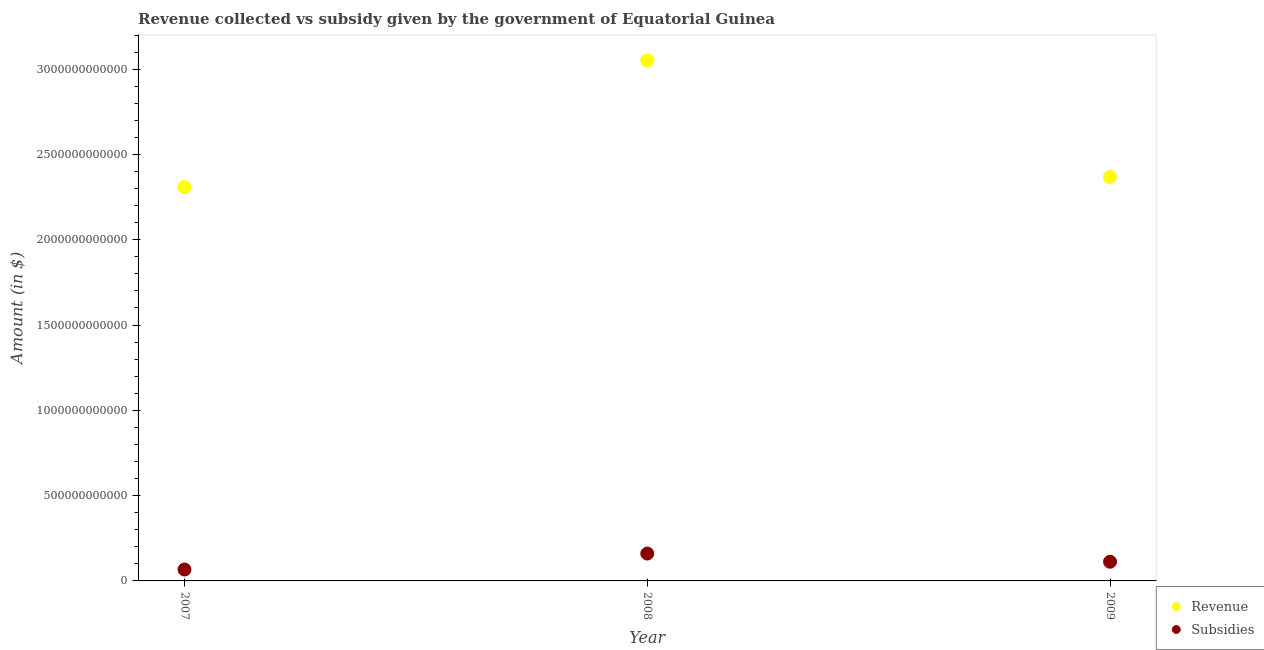How many different coloured dotlines are there?
Your response must be concise. 2. Is the number of dotlines equal to the number of legend labels?
Make the answer very short. Yes. What is the amount of subsidies given in 2009?
Keep it short and to the point. 1.12e+11. Across all years, what is the maximum amount of revenue collected?
Provide a short and direct response. 3.05e+12. Across all years, what is the minimum amount of subsidies given?
Offer a terse response. 6.67e+1. In which year was the amount of revenue collected maximum?
Keep it short and to the point. 2008. In which year was the amount of subsidies given minimum?
Make the answer very short. 2007. What is the total amount of subsidies given in the graph?
Ensure brevity in your answer.  3.40e+11. What is the difference between the amount of revenue collected in 2008 and that in 2009?
Make the answer very short. 6.84e+11. What is the difference between the amount of subsidies given in 2009 and the amount of revenue collected in 2008?
Ensure brevity in your answer.  -2.94e+12. What is the average amount of subsidies given per year?
Ensure brevity in your answer.  1.13e+11. In the year 2008, what is the difference between the amount of subsidies given and amount of revenue collected?
Your response must be concise. -2.89e+12. In how many years, is the amount of subsidies given greater than 1400000000000 $?
Keep it short and to the point. 0. What is the ratio of the amount of revenue collected in 2008 to that in 2009?
Make the answer very short. 1.29. Is the difference between the amount of revenue collected in 2007 and 2009 greater than the difference between the amount of subsidies given in 2007 and 2009?
Give a very brief answer. No. What is the difference between the highest and the second highest amount of subsidies given?
Provide a short and direct response. 4.80e+1. What is the difference between the highest and the lowest amount of subsidies given?
Provide a succinct answer. 9.38e+1. In how many years, is the amount of revenue collected greater than the average amount of revenue collected taken over all years?
Ensure brevity in your answer.  1. Is the amount of subsidies given strictly less than the amount of revenue collected over the years?
Offer a very short reply. Yes. What is the difference between two consecutive major ticks on the Y-axis?
Give a very brief answer. 5.00e+11. Does the graph contain any zero values?
Your answer should be compact. No. Where does the legend appear in the graph?
Provide a succinct answer. Bottom right. How many legend labels are there?
Provide a succinct answer. 2. What is the title of the graph?
Offer a very short reply. Revenue collected vs subsidy given by the government of Equatorial Guinea. What is the label or title of the Y-axis?
Ensure brevity in your answer.  Amount (in $). What is the Amount (in $) of Revenue in 2007?
Keep it short and to the point. 2.31e+12. What is the Amount (in $) of Subsidies in 2007?
Keep it short and to the point. 6.67e+1. What is the Amount (in $) in Revenue in 2008?
Ensure brevity in your answer.  3.05e+12. What is the Amount (in $) of Subsidies in 2008?
Offer a very short reply. 1.60e+11. What is the Amount (in $) in Revenue in 2009?
Provide a succinct answer. 2.37e+12. What is the Amount (in $) in Subsidies in 2009?
Keep it short and to the point. 1.12e+11. Across all years, what is the maximum Amount (in $) in Revenue?
Ensure brevity in your answer.  3.05e+12. Across all years, what is the maximum Amount (in $) of Subsidies?
Ensure brevity in your answer.  1.60e+11. Across all years, what is the minimum Amount (in $) in Revenue?
Offer a terse response. 2.31e+12. Across all years, what is the minimum Amount (in $) in Subsidies?
Provide a short and direct response. 6.67e+1. What is the total Amount (in $) of Revenue in the graph?
Ensure brevity in your answer.  7.73e+12. What is the total Amount (in $) of Subsidies in the graph?
Ensure brevity in your answer.  3.40e+11. What is the difference between the Amount (in $) of Revenue in 2007 and that in 2008?
Your answer should be compact. -7.43e+11. What is the difference between the Amount (in $) of Subsidies in 2007 and that in 2008?
Ensure brevity in your answer.  -9.38e+1. What is the difference between the Amount (in $) of Revenue in 2007 and that in 2009?
Make the answer very short. -5.96e+1. What is the difference between the Amount (in $) of Subsidies in 2007 and that in 2009?
Your response must be concise. -4.58e+1. What is the difference between the Amount (in $) of Revenue in 2008 and that in 2009?
Keep it short and to the point. 6.84e+11. What is the difference between the Amount (in $) in Subsidies in 2008 and that in 2009?
Provide a short and direct response. 4.80e+1. What is the difference between the Amount (in $) of Revenue in 2007 and the Amount (in $) of Subsidies in 2008?
Keep it short and to the point. 2.15e+12. What is the difference between the Amount (in $) in Revenue in 2007 and the Amount (in $) in Subsidies in 2009?
Offer a very short reply. 2.20e+12. What is the difference between the Amount (in $) in Revenue in 2008 and the Amount (in $) in Subsidies in 2009?
Your response must be concise. 2.94e+12. What is the average Amount (in $) in Revenue per year?
Ensure brevity in your answer.  2.58e+12. What is the average Amount (in $) in Subsidies per year?
Your answer should be very brief. 1.13e+11. In the year 2007, what is the difference between the Amount (in $) of Revenue and Amount (in $) of Subsidies?
Make the answer very short. 2.24e+12. In the year 2008, what is the difference between the Amount (in $) of Revenue and Amount (in $) of Subsidies?
Your response must be concise. 2.89e+12. In the year 2009, what is the difference between the Amount (in $) in Revenue and Amount (in $) in Subsidies?
Your answer should be compact. 2.26e+12. What is the ratio of the Amount (in $) of Revenue in 2007 to that in 2008?
Offer a terse response. 0.76. What is the ratio of the Amount (in $) in Subsidies in 2007 to that in 2008?
Offer a very short reply. 0.42. What is the ratio of the Amount (in $) in Revenue in 2007 to that in 2009?
Provide a succinct answer. 0.97. What is the ratio of the Amount (in $) of Subsidies in 2007 to that in 2009?
Give a very brief answer. 0.59. What is the ratio of the Amount (in $) in Revenue in 2008 to that in 2009?
Keep it short and to the point. 1.29. What is the ratio of the Amount (in $) in Subsidies in 2008 to that in 2009?
Keep it short and to the point. 1.43. What is the difference between the highest and the second highest Amount (in $) of Revenue?
Provide a short and direct response. 6.84e+11. What is the difference between the highest and the second highest Amount (in $) of Subsidies?
Your response must be concise. 4.80e+1. What is the difference between the highest and the lowest Amount (in $) of Revenue?
Make the answer very short. 7.43e+11. What is the difference between the highest and the lowest Amount (in $) of Subsidies?
Your response must be concise. 9.38e+1. 